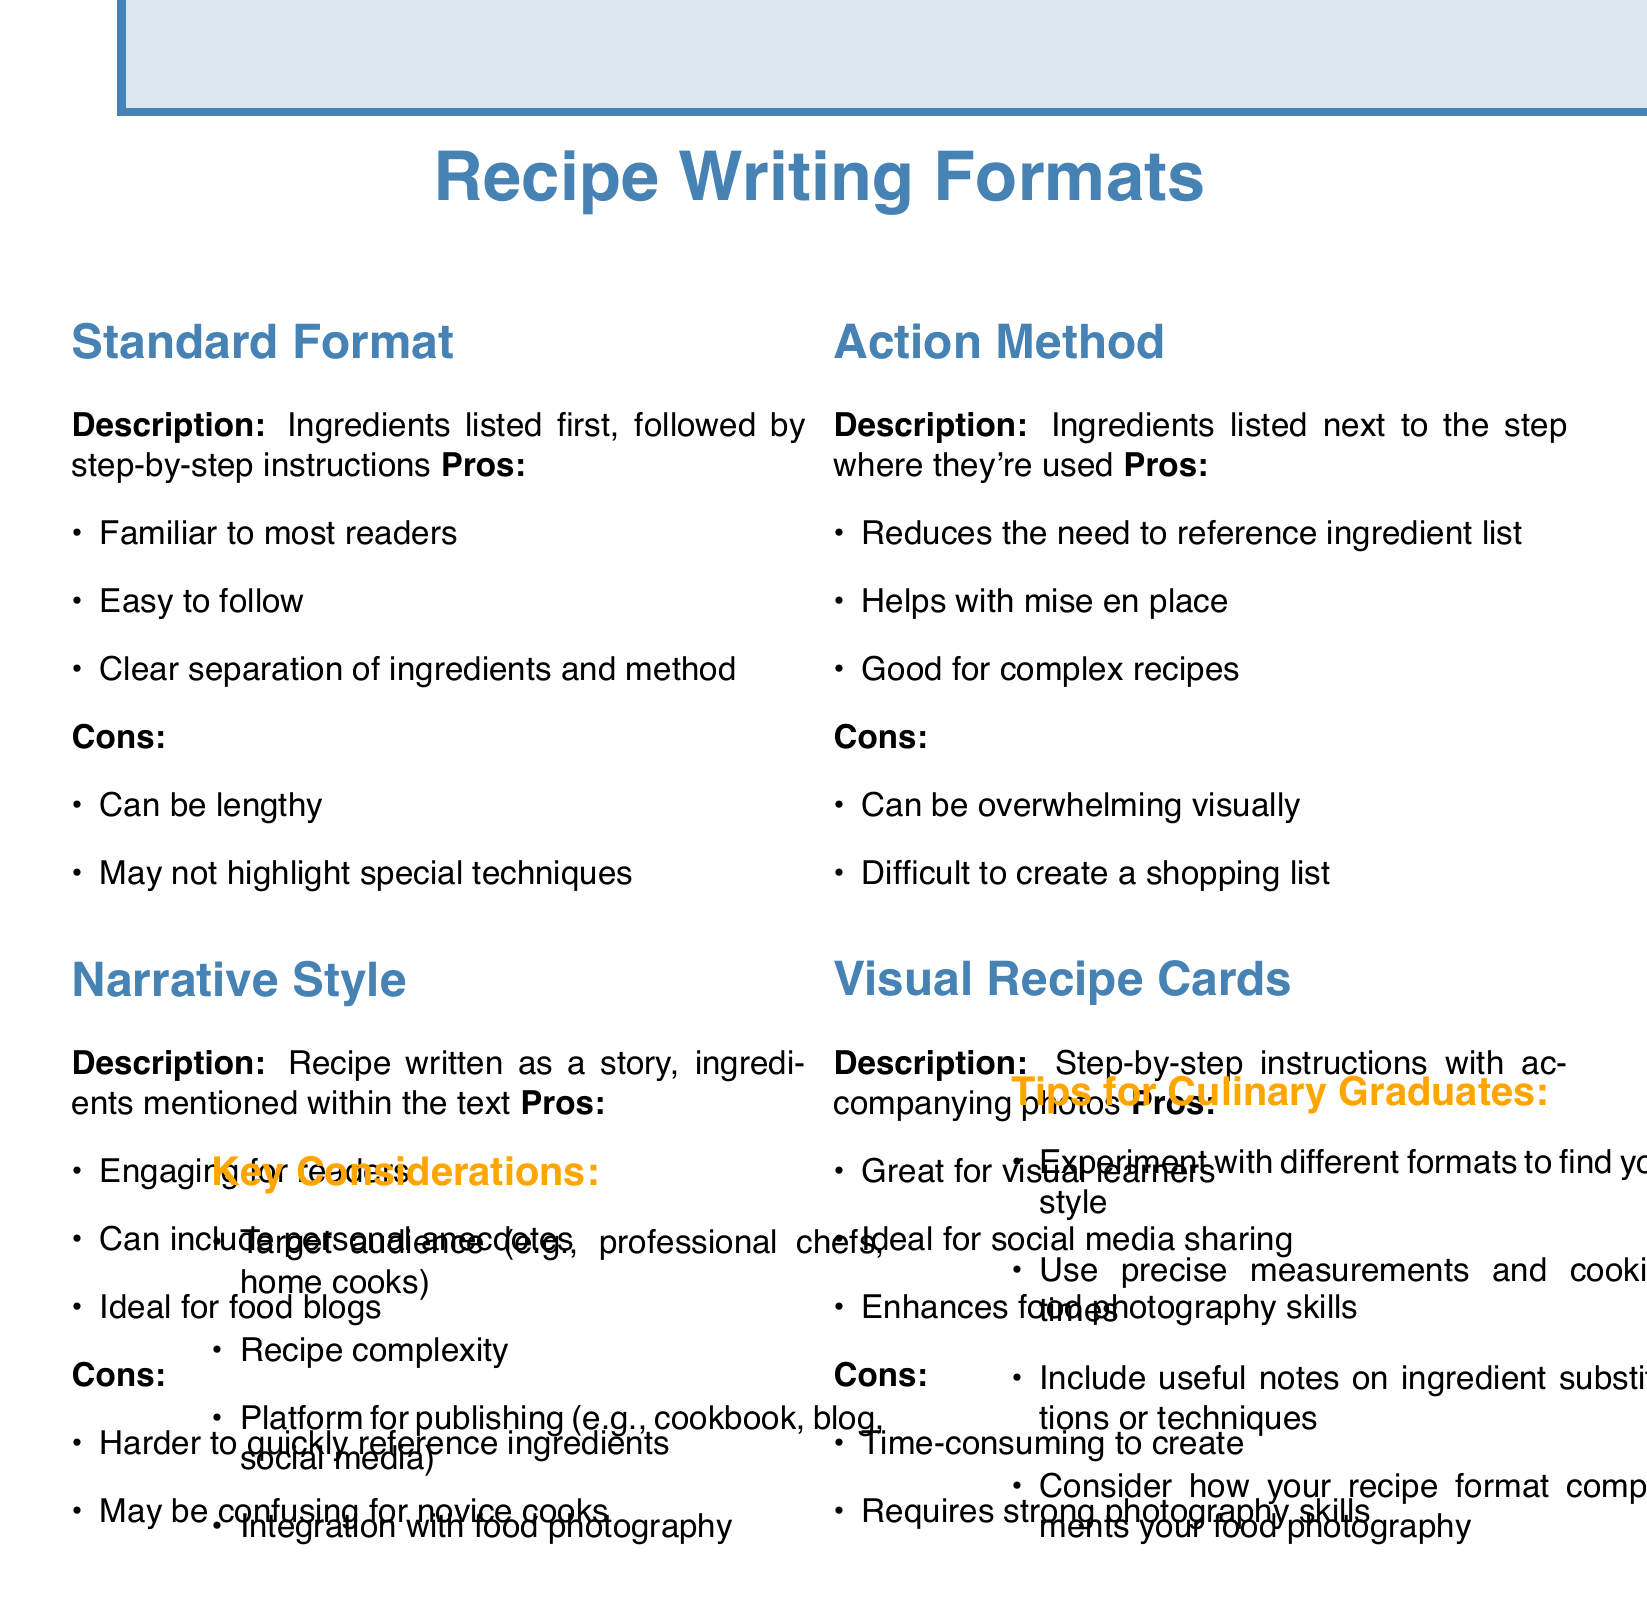What is the description of the Standard Format? The Standard Format describes that ingredients are listed first, followed by step-by-step instructions.
Answer: Ingredients listed first, followed by step-by-step instructions What is one pro of the Narrative Style? One pro of the Narrative Style is that it is engaging for readers.
Answer: Engaging for readers What is a con of the Action Method? A con of the Action Method is that it can be overwhelming visually.
Answer: Can be overwhelming visually Which recipe writing format is ideal for social media sharing? The Visual Recipe Cards format is ideal for social media sharing.
Answer: Visual Recipe Cards What is a key consideration when writing a recipe? Target audience is a key consideration when writing a recipe.
Answer: Target audience How many pros are listed for the Standard Format? There are three pros listed for the Standard Format.
Answer: Three What should culinary graduates experiment with according to the tips? Culinary graduates should experiment with different formats to find their style.
Answer: Different formats What enhances food photography skills? The Visual Recipe Cards format enhances food photography skills.
Answer: Visual Recipe Cards What is the description of the Action Method? The Action Method describes that ingredients are listed next to the step where they're used.
Answer: Ingredients listed next to the step where they're used 